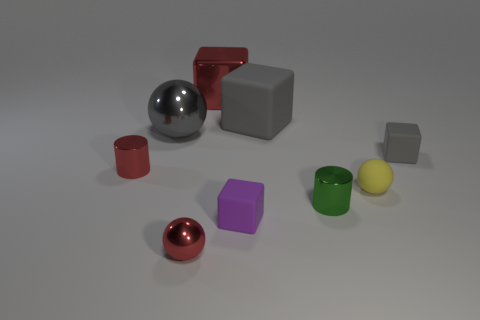Subtract all tiny rubber balls. How many balls are left? 2 Subtract all purple blocks. How many blocks are left? 3 Subtract 2 spheres. How many spheres are left? 1 Subtract all yellow cubes. How many cyan cylinders are left? 0 Subtract all small cylinders. Subtract all tiny yellow things. How many objects are left? 6 Add 1 small gray matte blocks. How many small gray matte blocks are left? 2 Add 1 big rubber things. How many big rubber things exist? 2 Subtract 0 yellow cylinders. How many objects are left? 9 Subtract all spheres. How many objects are left? 6 Subtract all brown blocks. Subtract all yellow cylinders. How many blocks are left? 4 